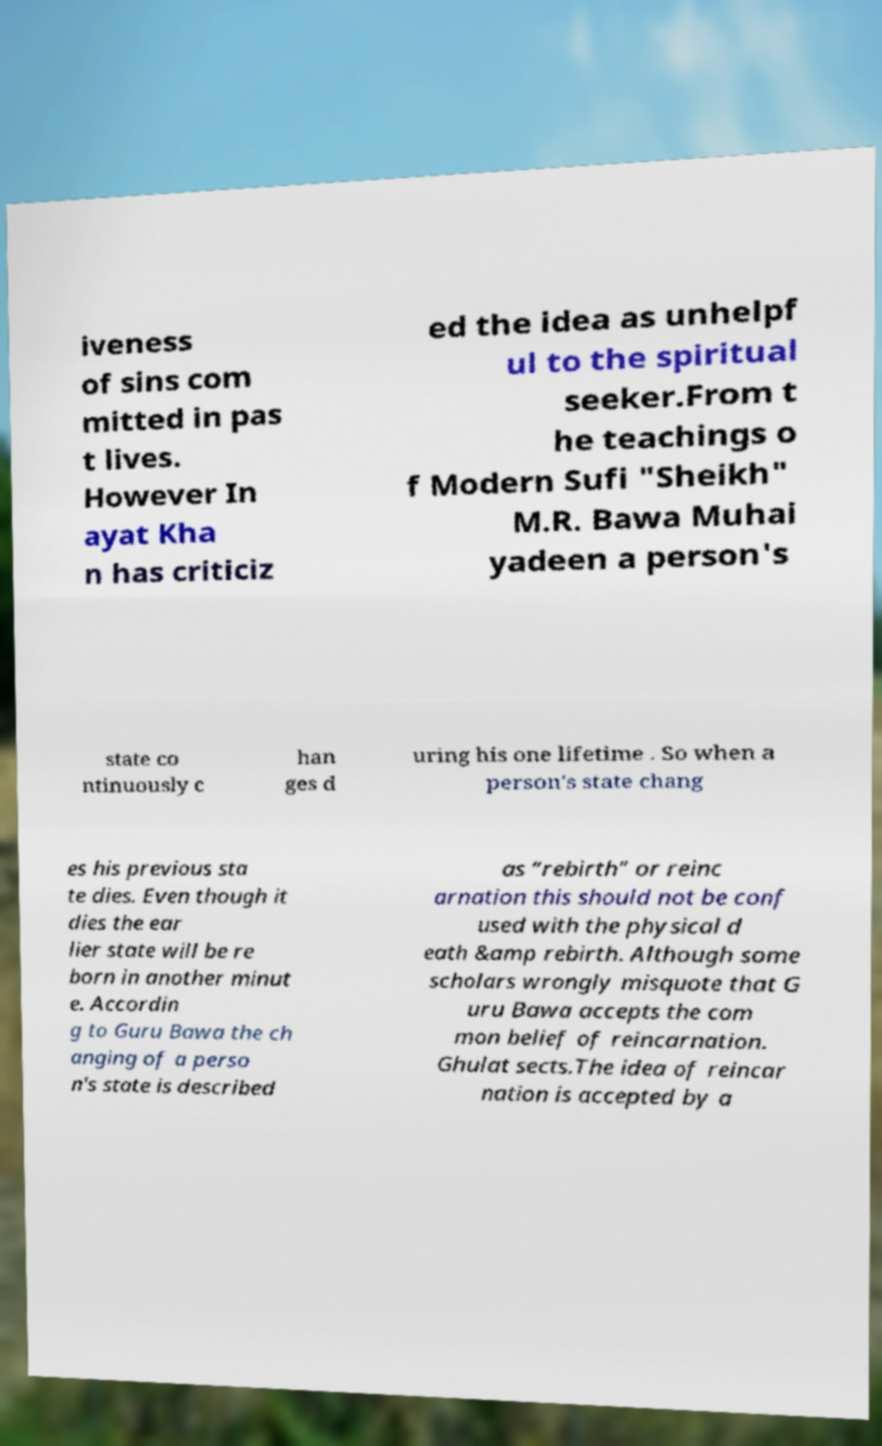I need the written content from this picture converted into text. Can you do that? iveness of sins com mitted in pas t lives. However In ayat Kha n has criticiz ed the idea as unhelpf ul to the spiritual seeker.From t he teachings o f Modern Sufi "Sheikh" M.R. Bawa Muhai yadeen a person's state co ntinuously c han ges d uring his one lifetime . So when a person's state chang es his previous sta te dies. Even though it dies the ear lier state will be re born in another minut e. Accordin g to Guru Bawa the ch anging of a perso n's state is described as “rebirth” or reinc arnation this should not be conf used with the physical d eath &amp rebirth. Although some scholars wrongly misquote that G uru Bawa accepts the com mon belief of reincarnation. Ghulat sects.The idea of reincar nation is accepted by a 